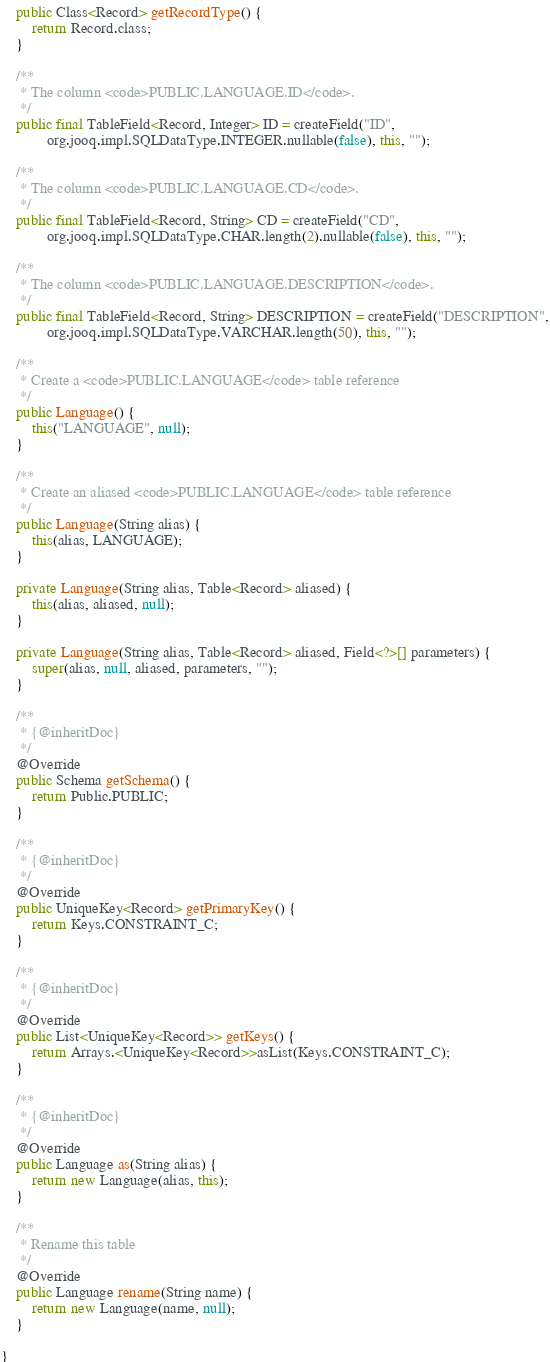<code> <loc_0><loc_0><loc_500><loc_500><_Java_>	public Class<Record> getRecordType() {
		return Record.class;
	}

	/**
	 * The column <code>PUBLIC.LANGUAGE.ID</code>.
	 */
	public final TableField<Record, Integer> ID = createField("ID",
			org.jooq.impl.SQLDataType.INTEGER.nullable(false), this, "");

	/**
	 * The column <code>PUBLIC.LANGUAGE.CD</code>.
	 */
	public final TableField<Record, String> CD = createField("CD",
			org.jooq.impl.SQLDataType.CHAR.length(2).nullable(false), this, "");

	/**
	 * The column <code>PUBLIC.LANGUAGE.DESCRIPTION</code>.
	 */
	public final TableField<Record, String> DESCRIPTION = createField("DESCRIPTION",
			org.jooq.impl.SQLDataType.VARCHAR.length(50), this, "");

	/**
	 * Create a <code>PUBLIC.LANGUAGE</code> table reference
	 */
	public Language() {
		this("LANGUAGE", null);
	}

	/**
	 * Create an aliased <code>PUBLIC.LANGUAGE</code> table reference
	 */
	public Language(String alias) {
		this(alias, LANGUAGE);
	}

	private Language(String alias, Table<Record> aliased) {
		this(alias, aliased, null);
	}

	private Language(String alias, Table<Record> aliased, Field<?>[] parameters) {
		super(alias, null, aliased, parameters, "");
	}

	/**
	 * {@inheritDoc}
	 */
	@Override
	public Schema getSchema() {
		return Public.PUBLIC;
	}

	/**
	 * {@inheritDoc}
	 */
	@Override
	public UniqueKey<Record> getPrimaryKey() {
		return Keys.CONSTRAINT_C;
	}

	/**
	 * {@inheritDoc}
	 */
	@Override
	public List<UniqueKey<Record>> getKeys() {
		return Arrays.<UniqueKey<Record>>asList(Keys.CONSTRAINT_C);
	}

	/**
	 * {@inheritDoc}
	 */
	@Override
	public Language as(String alias) {
		return new Language(alias, this);
	}

	/**
	 * Rename this table
	 */
	@Override
	public Language rename(String name) {
		return new Language(name, null);
	}

}
</code> 